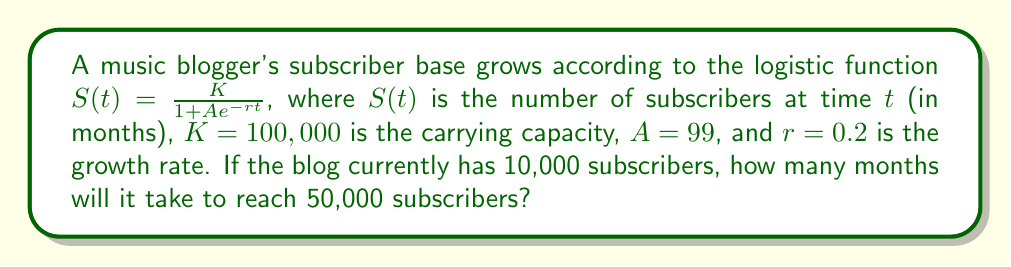What is the answer to this math problem? 1. We start with the logistic function: $S(t) = \frac{K}{1 + Ae^{-rt}}$

2. We know that $K = 100,000$, $A = 99$, and $r = 0.2$. We want to find $t$ when $S(t) = 50,000$.

3. Substitute these values into the equation:
   $50,000 = \frac{100,000}{1 + 99e^{-0.2t}}$

4. Simplify:
   $\frac{1}{2} = \frac{1}{1 + 99e^{-0.2t}}$

5. Take the reciprocal of both sides:
   $2 = 1 + 99e^{-0.2t}$

6. Subtract 1 from both sides:
   $1 = 99e^{-0.2t}$

7. Divide both sides by 99:
   $\frac{1}{99} = e^{-0.2t}$

8. Take the natural logarithm of both sides:
   $\ln(\frac{1}{99}) = -0.2t$

9. Divide both sides by -0.2:
   $\frac{\ln(\frac{1}{99})}{-0.2} = t$

10. Simplify:
    $t = \frac{\ln(99)}{0.2} \approx 23.025$

11. Round up to the nearest month:
    $t = 24$ months
Answer: 24 months 